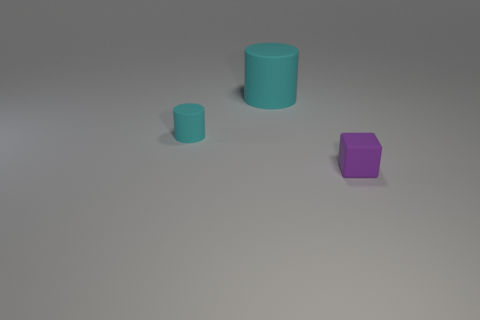Add 3 large yellow cubes. How many objects exist? 6 Subtract all cylinders. How many objects are left? 1 Add 1 tiny things. How many tiny things exist? 3 Subtract 0 brown spheres. How many objects are left? 3 Subtract all yellow matte cylinders. Subtract all small purple matte objects. How many objects are left? 2 Add 1 big cylinders. How many big cylinders are left? 2 